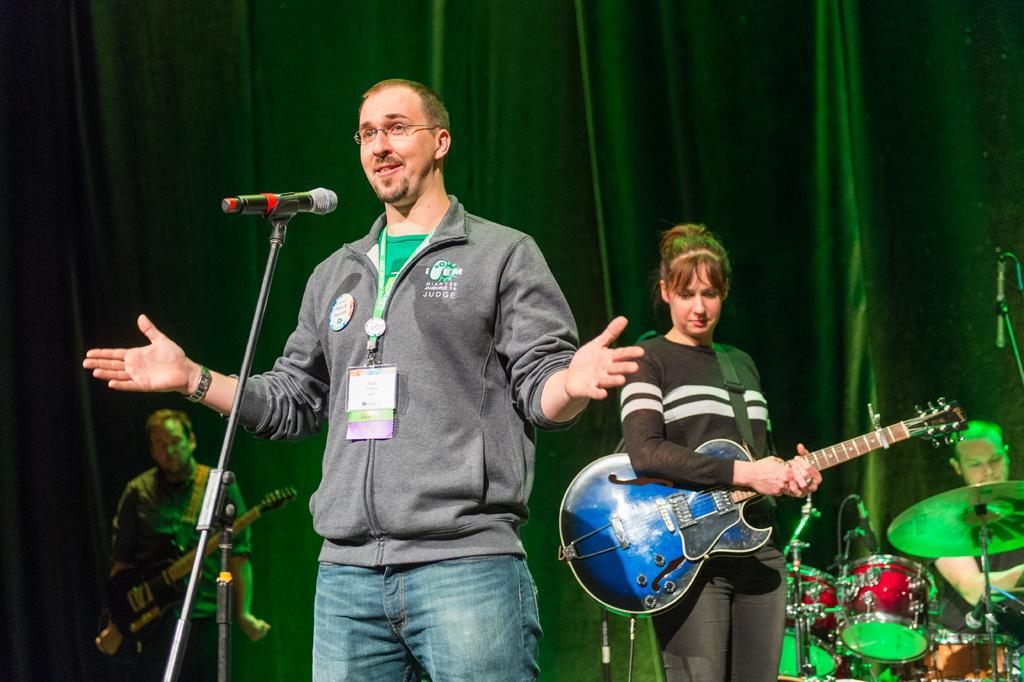In one or two sentences, can you explain what this image depicts? In this picture we can see a man in the jacket and the man wore the tags. In front of the man there is a microphone with stand. Behind the man there are two people holding the musical instruments and a person is sitting. In front of the sitting person there are some musical instruments and a stand. Behind the people, it looks like a curtain. 